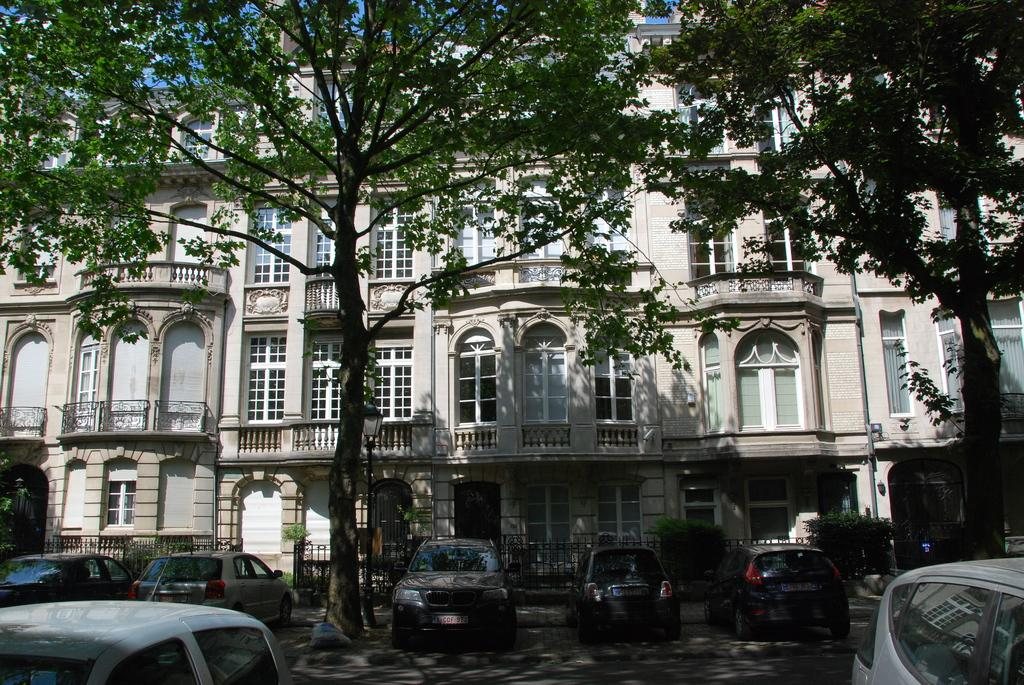What type of natural elements can be seen in the image? There are trees and plants in the image. What type of man-made structure is present in the image? There is a building in the image. What type of architectural feature can be seen in the image? There are grilles in the image. What type of transportation is visible in the image? There are vehicles in the image. What is visible in the sky in the image? The sky is visible in the image. Can you see any mice running around in the image? There are no mice present in the image. What type of paste is used to hold the grilles together in the image? There is no mention of paste or any adhesive being used to hold the grilles together in the image. 